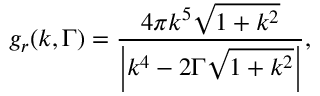<formula> <loc_0><loc_0><loc_500><loc_500>{ g _ { r } } ( k , \Gamma ) = \frac { { 4 \pi { k ^ { 5 } } \sqrt { 1 + { k ^ { 2 } } } } } { { \left | { { k ^ { 4 } } - 2 \Gamma \sqrt { 1 + { k ^ { 2 } } } } \right | } } ,</formula> 